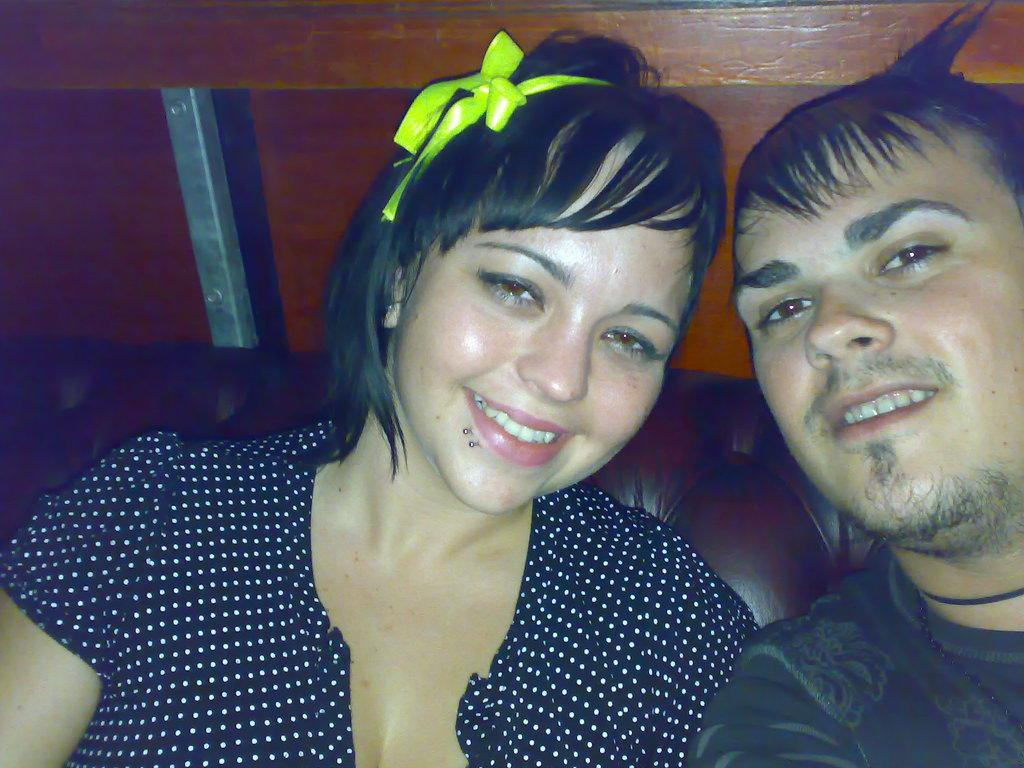Who can be seen in the image? There is a man and a woman in the image. What are the facial expressions of the man and woman? Both the man and woman are smiling in the image. What color are the clothes worn by the man and woman? The man and woman are wearing dark color clothes. What can be seen in the background of the image? There are objects in the background of the image. What is the annual income of the man and woman in the image? The provided facts do not mention any information about the man and woman's income, so it cannot be determined from the image. 